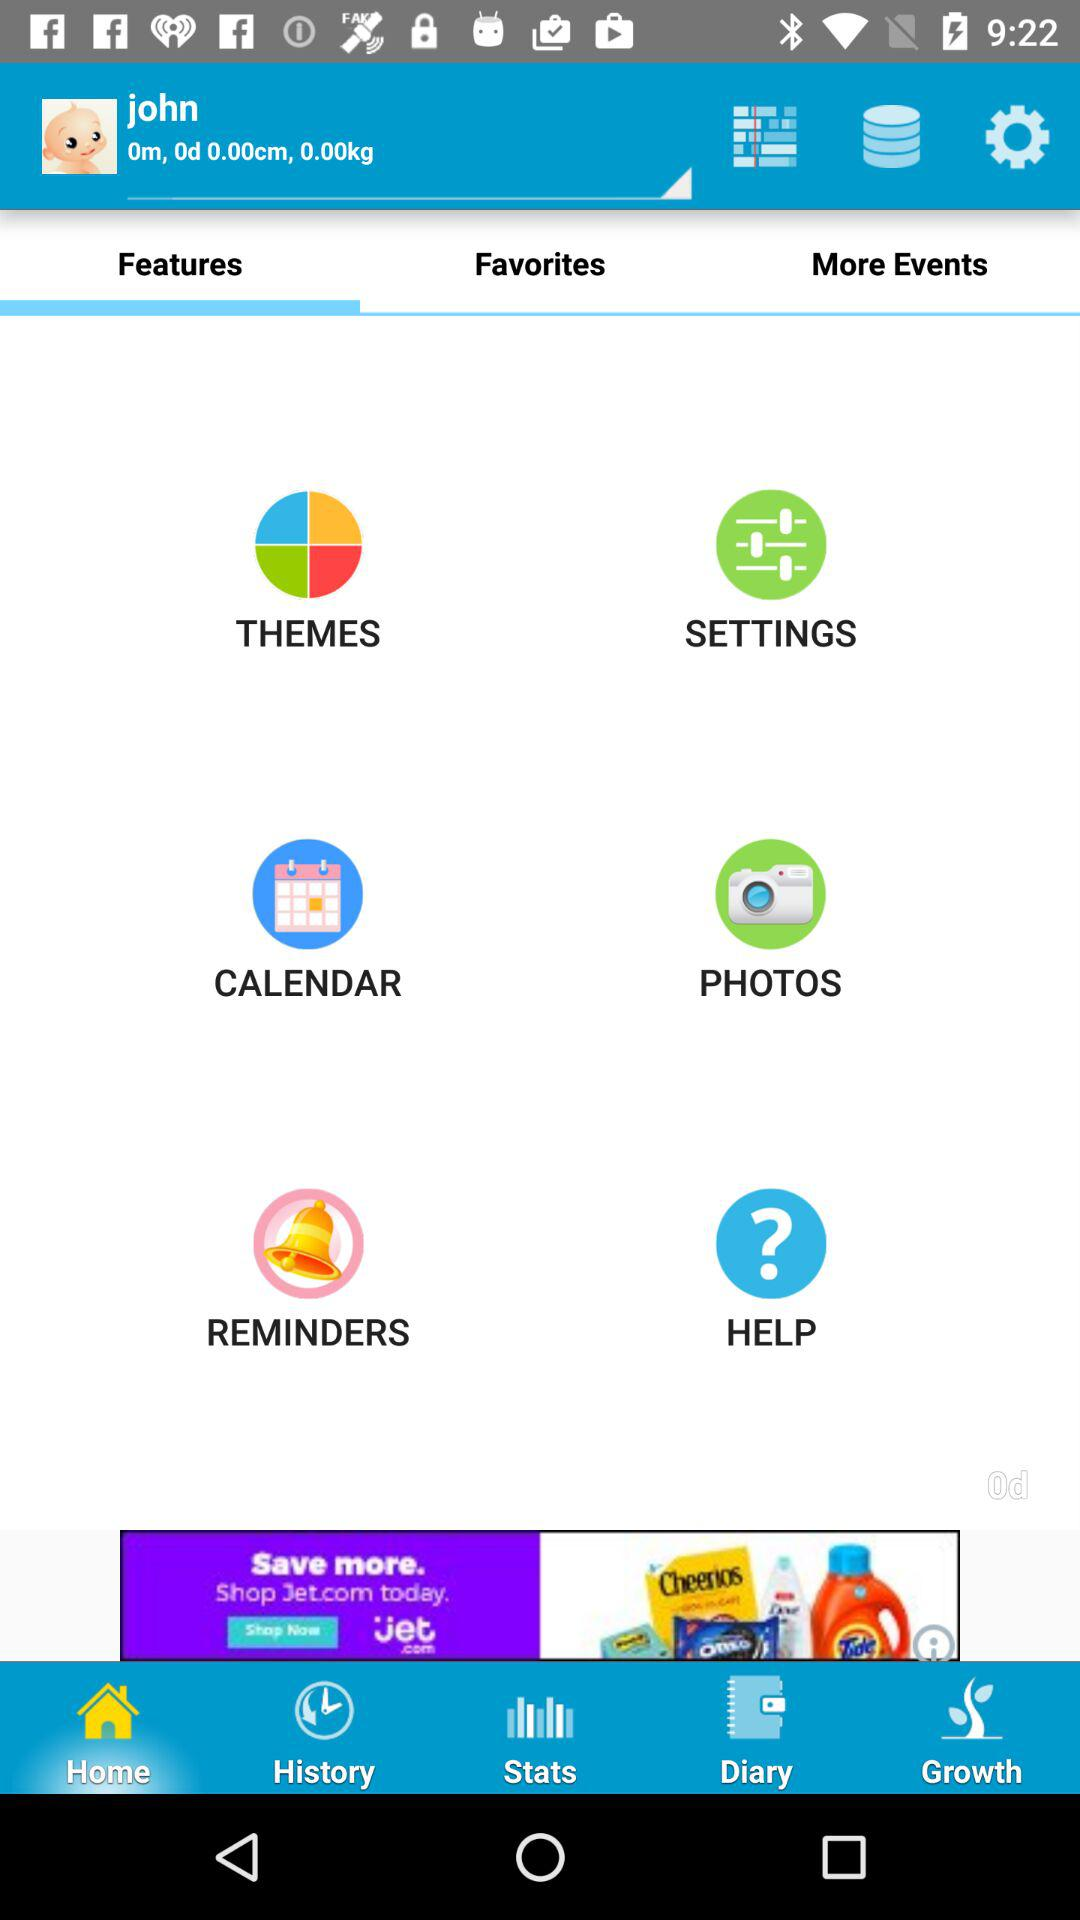What's the name of the baby? The name of the baby is John. 